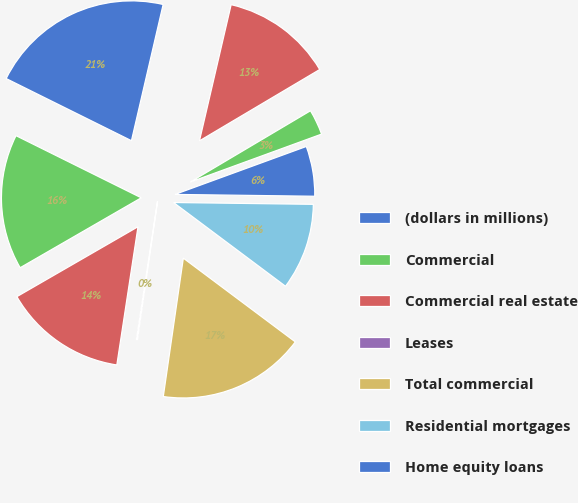Convert chart. <chart><loc_0><loc_0><loc_500><loc_500><pie_chart><fcel>(dollars in millions)<fcel>Commercial<fcel>Commercial real estate<fcel>Leases<fcel>Total commercial<fcel>Residential mortgages<fcel>Home equity loans<fcel>Home equity lines of credit<fcel>Home equity loans serviced by<nl><fcel>21.31%<fcel>15.66%<fcel>14.25%<fcel>0.13%<fcel>17.07%<fcel>10.01%<fcel>5.78%<fcel>2.95%<fcel>12.84%<nl></chart> 